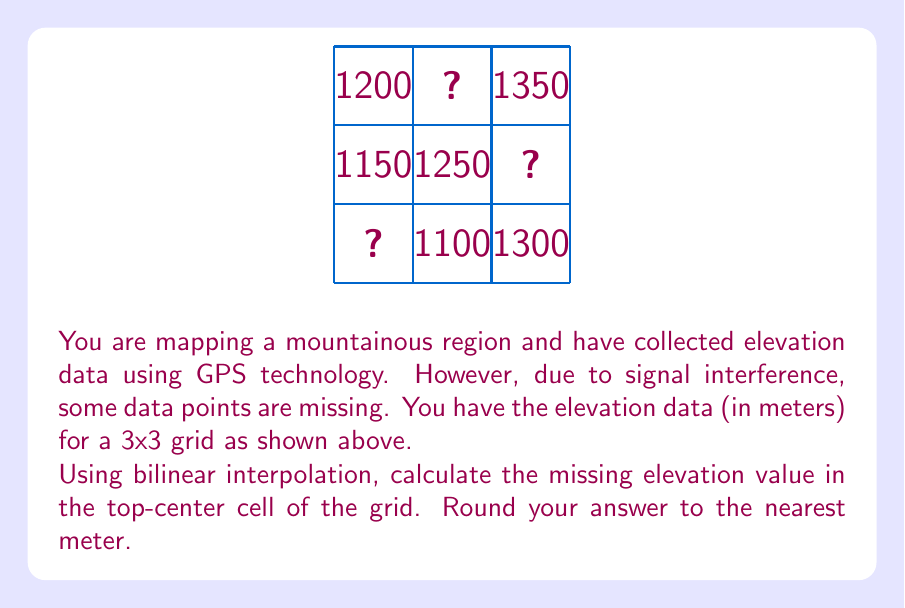Show me your answer to this math problem. To solve this problem, we'll use bilinear interpolation to estimate the missing elevation value. Bilinear interpolation is a method of interpolating the value of a function of two variables on a rectilinear 2D grid.

Steps:

1) First, we need to interpolate along the x-axis for the top row and bottom row.

2) For the top row:
   We have values 1200 and 1350, with the unknown point in the middle.
   Linear interpolation: $1200 + (1350 - 1200) * 0.5 = 1275$

3) For the bottom row:
   We have values 1100 and 1300.
   Linear interpolation: $1100 + (1300 - 1100) * 0.5 = 1200$

4) Now we have three points vertically aligned:
   Top: 1275
   Middle: 1250 (given)
   Bottom: 1200

5) We perform linear interpolation along the y-axis:
   $1200 + (1275 - 1200) * \frac{2}{3} = 1250$

6) The interpolated value is 1250 meters.

7) Rounding to the nearest meter: 1250 meters.

This method assumes a linear change in elevation between known points, which is a reasonable approximation for many terrain features.
Answer: 1250 meters 